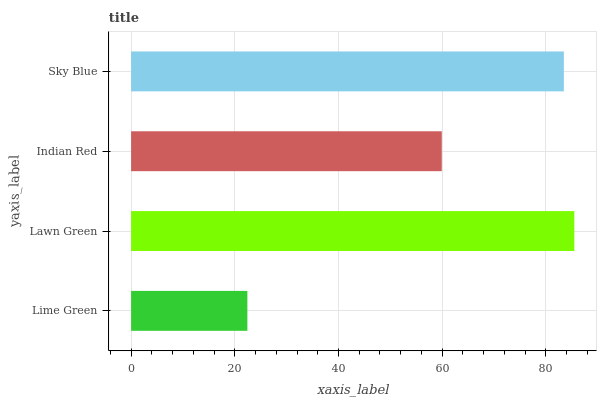Is Lime Green the minimum?
Answer yes or no. Yes. Is Lawn Green the maximum?
Answer yes or no. Yes. Is Indian Red the minimum?
Answer yes or no. No. Is Indian Red the maximum?
Answer yes or no. No. Is Lawn Green greater than Indian Red?
Answer yes or no. Yes. Is Indian Red less than Lawn Green?
Answer yes or no. Yes. Is Indian Red greater than Lawn Green?
Answer yes or no. No. Is Lawn Green less than Indian Red?
Answer yes or no. No. Is Sky Blue the high median?
Answer yes or no. Yes. Is Indian Red the low median?
Answer yes or no. Yes. Is Indian Red the high median?
Answer yes or no. No. Is Lawn Green the low median?
Answer yes or no. No. 